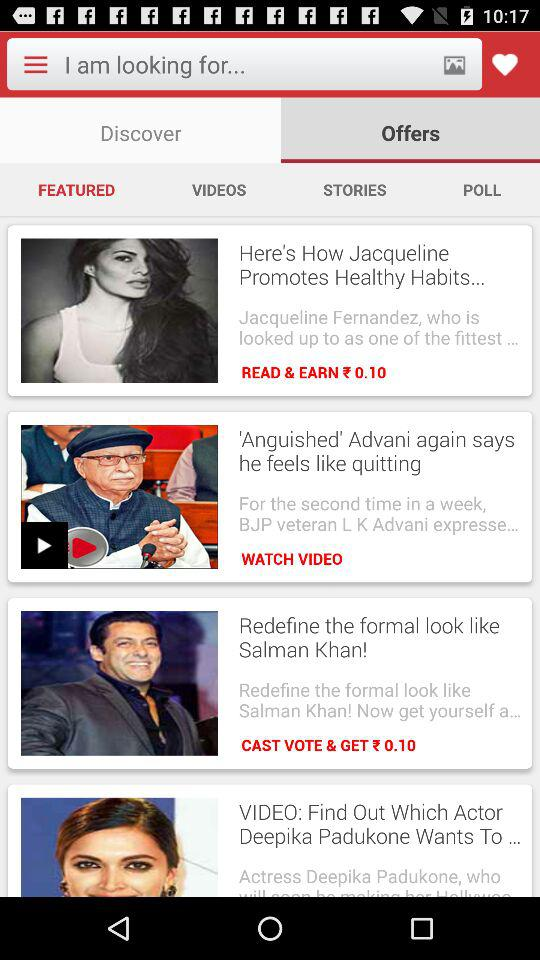Which tab is currently selected? The currently selected tabs are "Offers" and "FEATURED". 